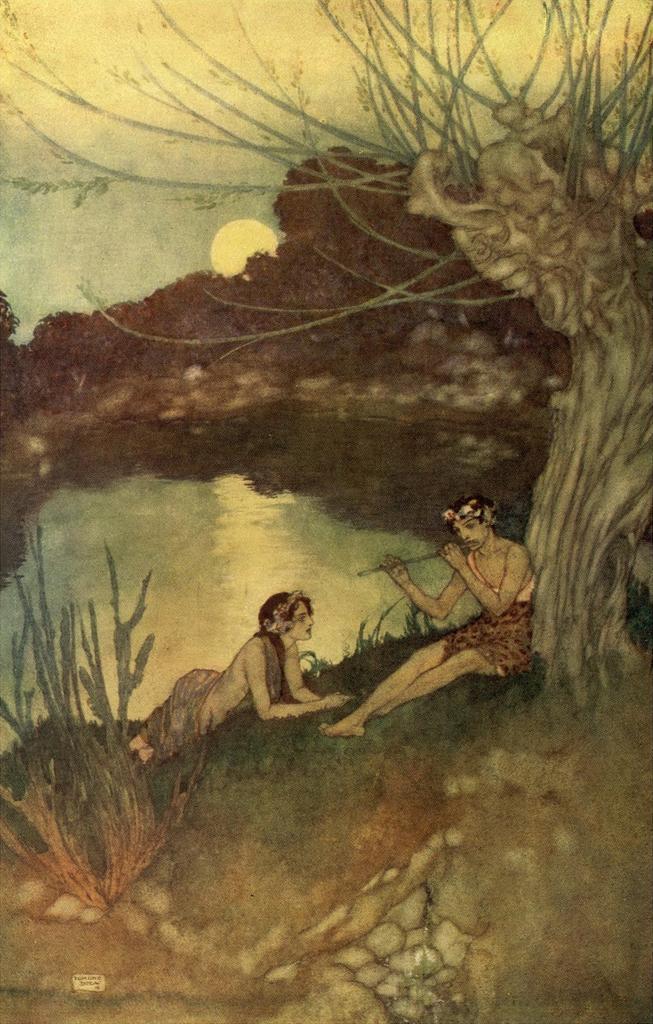Please provide a concise description of this image. This image consists of a painting in which there are two persons sitting near the tree. In the middle, there is water. In the background, there are trees along with the sun in the sky. 